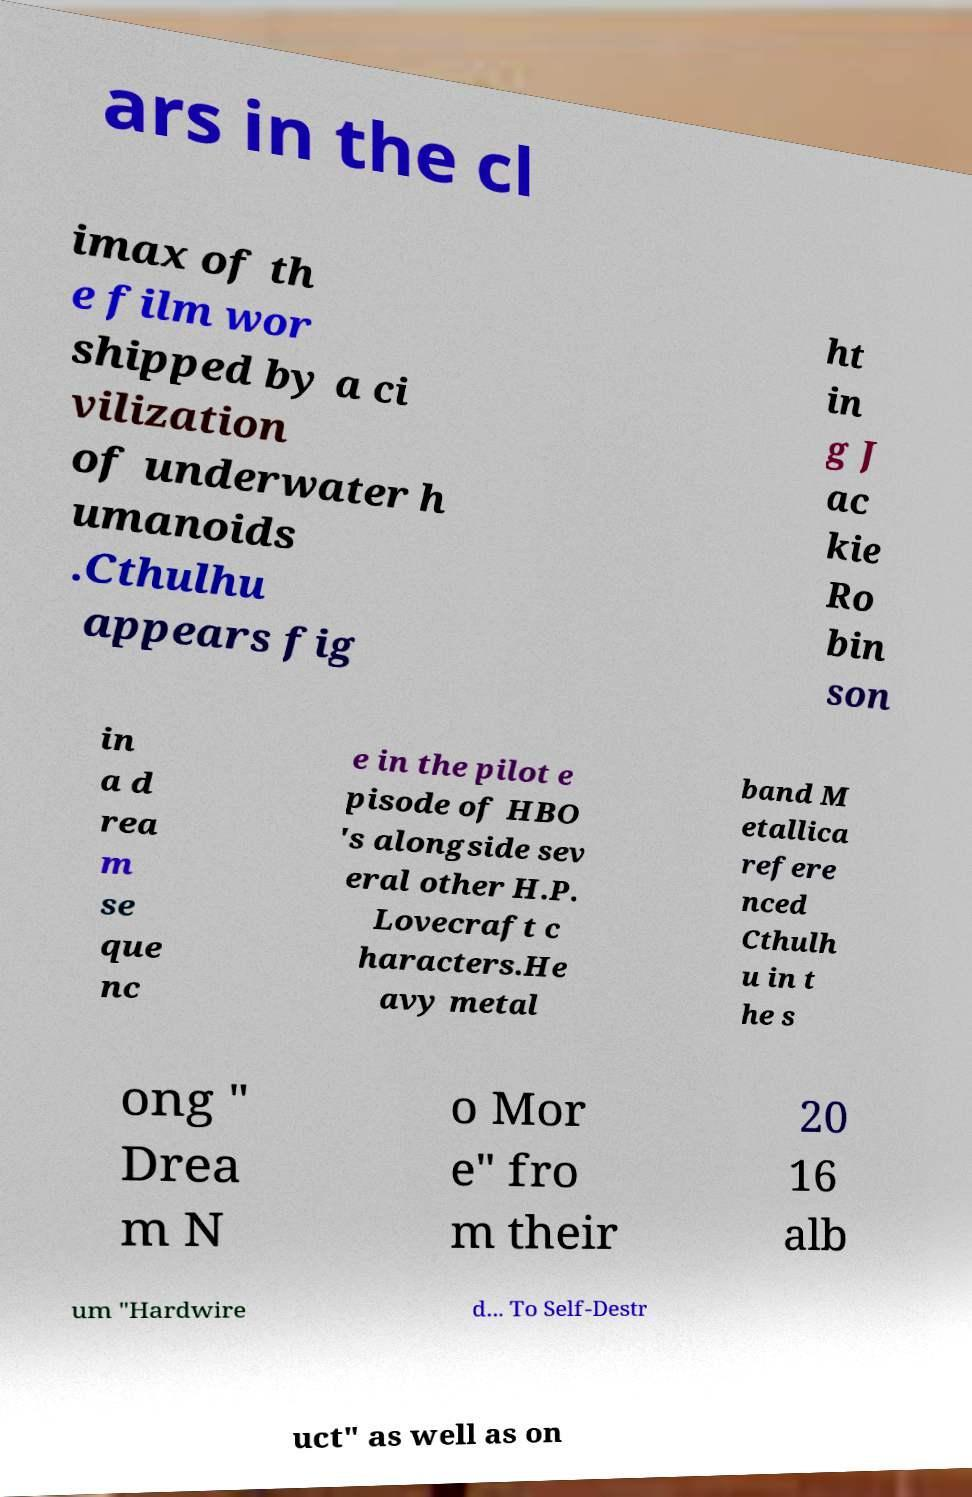For documentation purposes, I need the text within this image transcribed. Could you provide that? ars in the cl imax of th e film wor shipped by a ci vilization of underwater h umanoids .Cthulhu appears fig ht in g J ac kie Ro bin son in a d rea m se que nc e in the pilot e pisode of HBO 's alongside sev eral other H.P. Lovecraft c haracters.He avy metal band M etallica refere nced Cthulh u in t he s ong " Drea m N o Mor e" fro m their 20 16 alb um "Hardwire d... To Self-Destr uct" as well as on 